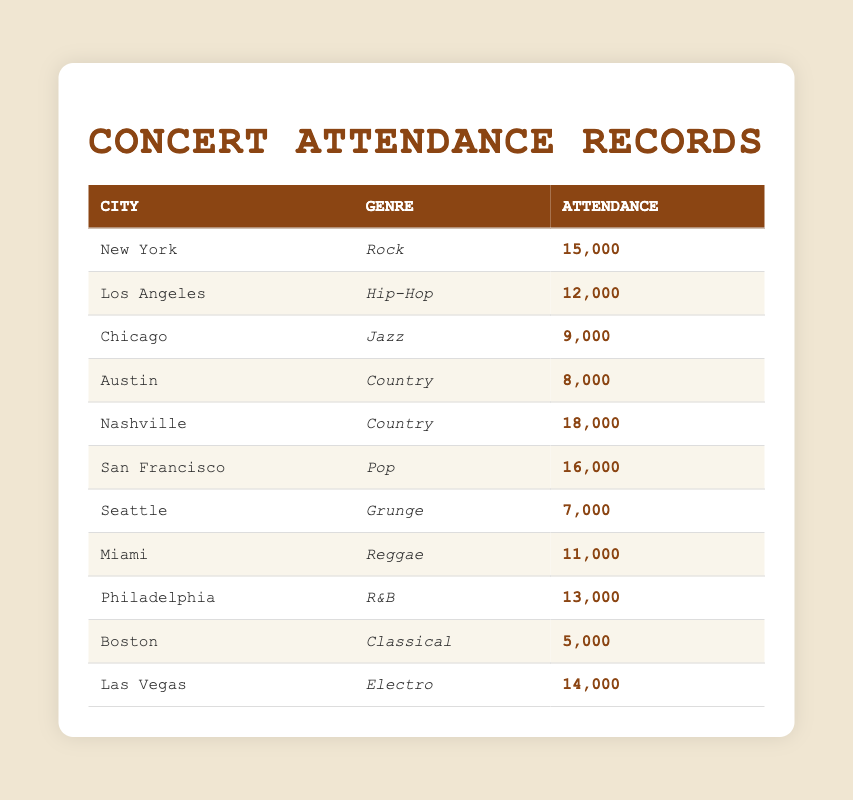What city had the highest concert attendance? By examining the attendance figures in the table, New York is listed with an attendance of 15,000, while Nashville has the highest attendance of 18,000. Thus, Nashville had the highest concert attendance among the cities listed.
Answer: Nashville Which genre had the lowest concert attendance? Looking through the table, the attendance for Boston, which hosted a Classical concert, is 5,000, the lowest compared to all other genres listed in the table.
Answer: Classical What is the total concert attendance for Country music? There are two cities listed under the Country genre: Austin with 8,000 and Nashville with 18,000. Adding these two figures together gives 8,000 + 18,000 = 26,000 as the total attendance for Country music.
Answer: 26000 Is the total attendance for Pop concerts greater than Hip-Hop concerts? The attendance for San Francisco (Pop) is 16,000, and for Los Angeles (Hip-Hop), it's 12,000. Since 16,000 (Pop) is greater than 12,000 (Hip-Hop), the statement holds true.
Answer: Yes What is the average concert attendance across all cities? The total concert attendance is the sum of all individual attendances: 15,000 + 12,000 + 9,000 + 8,000 + 18,000 + 16,000 + 7,000 + 11,000 + 13,000 + 5,000 + 14,000 =  117,000. There are 11 concerts in total, so the average attendance is 117,000 / 11 = 10,636.36, which rounds to 10,636.
Answer: 10636 